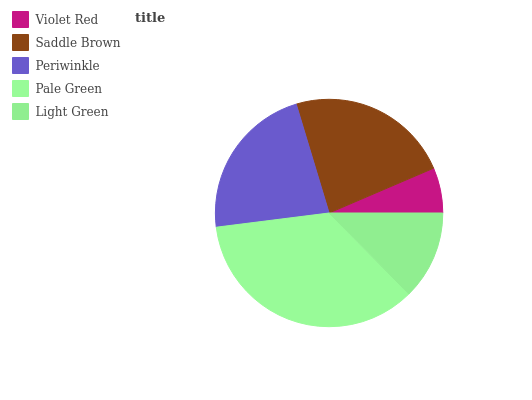Is Violet Red the minimum?
Answer yes or no. Yes. Is Pale Green the maximum?
Answer yes or no. Yes. Is Saddle Brown the minimum?
Answer yes or no. No. Is Saddle Brown the maximum?
Answer yes or no. No. Is Saddle Brown greater than Violet Red?
Answer yes or no. Yes. Is Violet Red less than Saddle Brown?
Answer yes or no. Yes. Is Violet Red greater than Saddle Brown?
Answer yes or no. No. Is Saddle Brown less than Violet Red?
Answer yes or no. No. Is Periwinkle the high median?
Answer yes or no. Yes. Is Periwinkle the low median?
Answer yes or no. Yes. Is Light Green the high median?
Answer yes or no. No. Is Violet Red the low median?
Answer yes or no. No. 